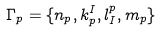Convert formula to latex. <formula><loc_0><loc_0><loc_500><loc_500>\Gamma _ { p } = \{ n _ { p } , k ^ { I } _ { p } , l _ { I } ^ { p } , m _ { p } \}</formula> 